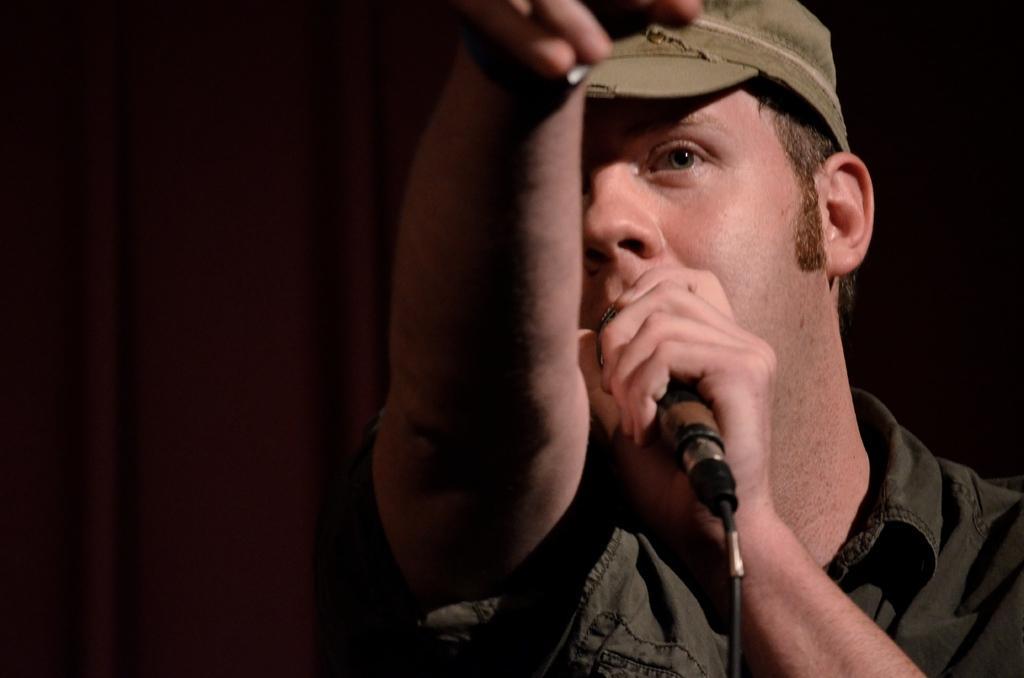What is the main subject of the picture? The main subject of the picture is a man. What is the man wearing on his head? The man is wearing a hat. What is the man holding in his hand? The man is holding a mic. What is the man doing in the picture? The man is speaking. What color is the background of the image? The background of the image is black. What is present to the man's left side? There is a curtain to the man's left side. What type of door can be seen in the background of the image? There is no door visible in the background of the image; it is black. What type of polish is the man applying to his shoes in the image? The man is not applying any polish to his shoes in the image; he is holding a mic and speaking. 